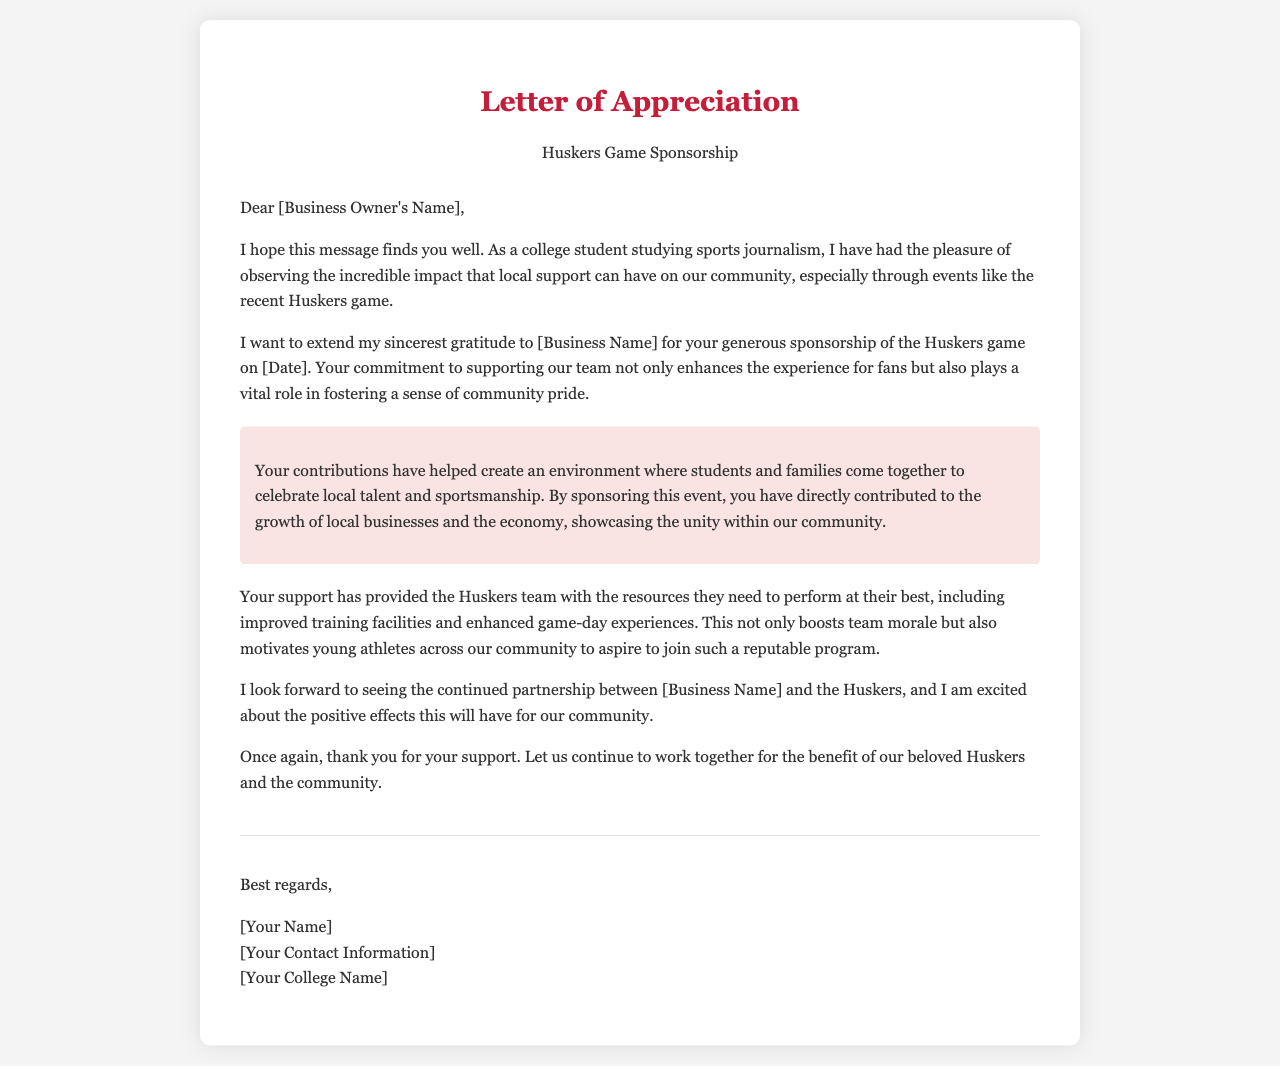What is the name of the business being appreciated? The business name is mentioned directly in the letter as the recipient of the appreciation.
Answer: [Business Name] Who wrote the letter? The author of the letter is indicated in the closing section as the individual expressing gratitude.
Answer: [Your Name] What is the date of the Huskers game? The date for the Huskers game is referred to in the letter, indicating when the sponsorship event took place.
Answer: [Date] What impact does the letter claim sponsorship has on the community? The letter highlights the positive effects of local sponsorship on community pride and economic growth.
Answer: Community pride and economic growth What does the letter express gratitude for? The letter specifically thanks the business for its support and sponsorship of a sporting event.
Answer: Sponsorship of the Huskers game What kind of contributions does the letter mention? The letter discusses contributions that help improve team resources and enhance fan experiences.
Answer: Improved training facilities and enhanced game-day experiences What future relationship does the letter anticipate? The letter looks forward to ongoing collaboration between the business and the Huskers team.
Answer: Continued partnership What is the tone of the letter? The overall tone of the letter is appreciative and positive regarding the impact of the sponsorship.
Answer: Appreciative and positive 